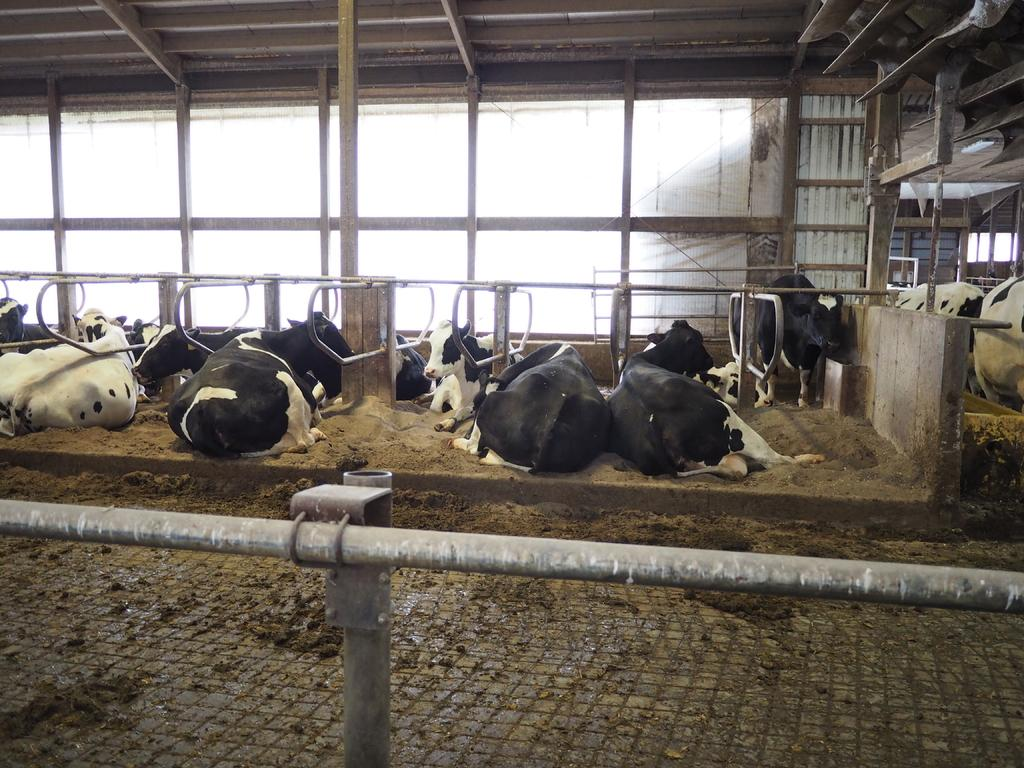What type of animals can be seen in the image? There are cows in the image. What architectural features are present in the image? There are pillars in the image. What other objects can be seen in the image? There are pipes in the image. What type of walls can be seen in the background of the image? There are glass walls visible in the background of the image. What type of pen is being used to write on the glass walls in the image? There is no pen or writing visible on the glass walls in the image. 